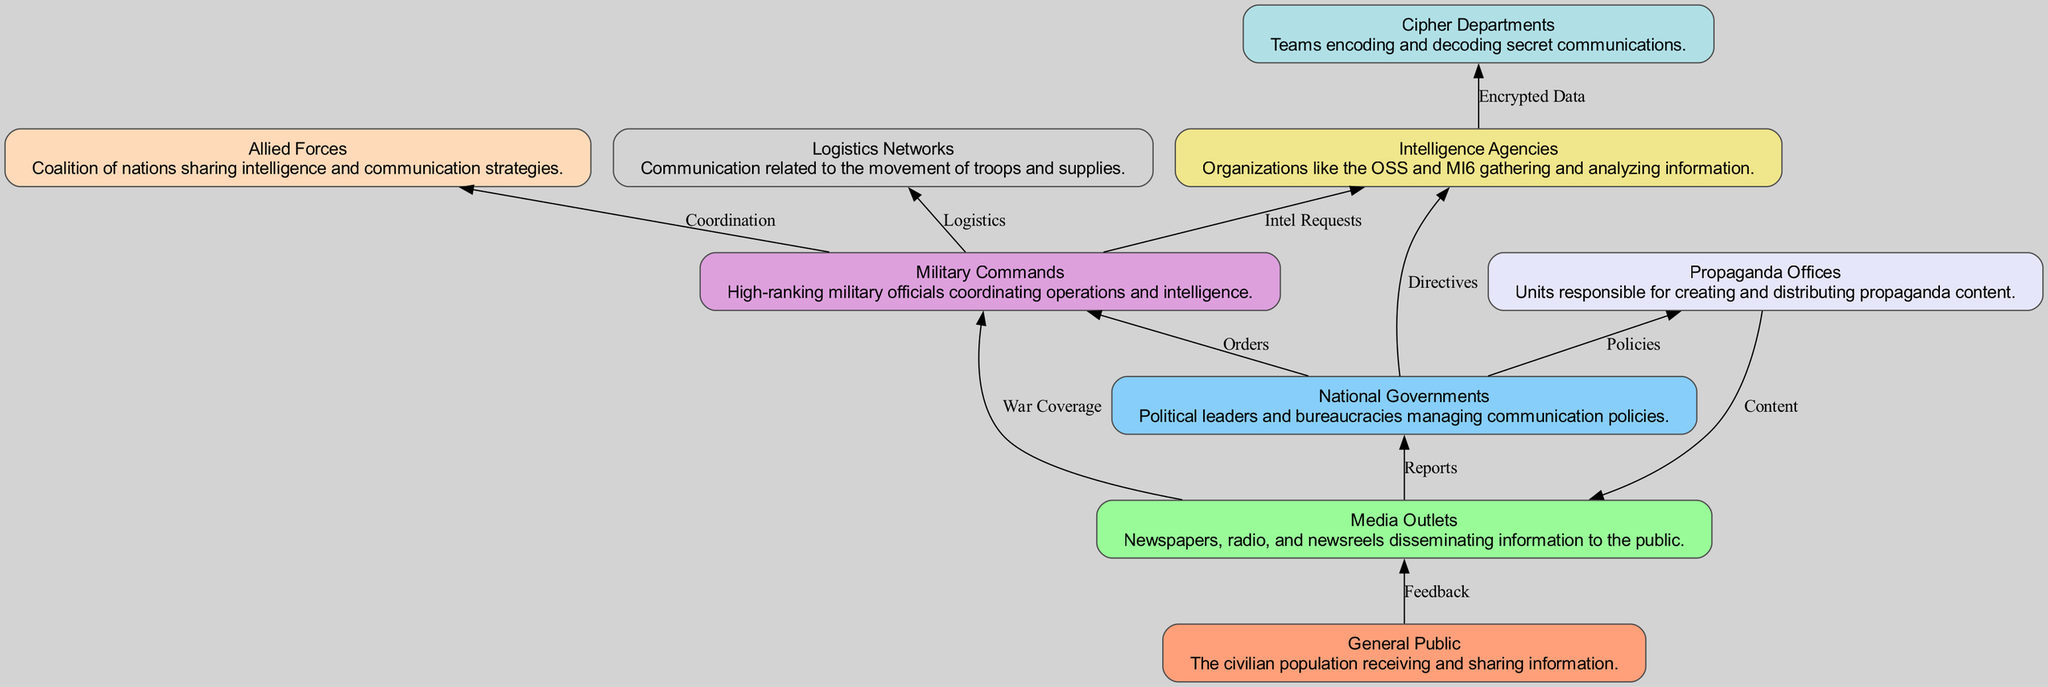What is the total number of nodes in the diagram? The diagram contains nodes representing different entities: General Public, Media Outlets, National Governments, Military Commands, Intelligence Agencies, Propaganda Offices, Allied Forces, Cipher Departments, and Logistics Networks. Counting these gives a total of 9 nodes.
Answer: 9 What is the relationship between the Media and the Government? In the diagram, the Media has a directed edge towards the Government, labeled as "Reports," indicating that Media Outlets send reports to National Governments.
Answer: Reports Who communicates directly with the Military for logistics? The diagram shows that the Military communicates with Logistics Networks with a directed edge labeled "Logistics." This means that Logistics Networks are responsible for facilitating communication about the movement of troops and supplies with the Military.
Answer: Logistics Networks Which entity is responsible for creating content shared by the Media? The directed edge from Propaganda Offices to Media Outlets, labeled "Content," indicates that the Propaganda Offices are responsible for creating content that is disseminated by the Media.
Answer: Propaganda Offices How many connections does the Intelligence Agencies have? By examining the edges leading into and out of Intelligence Agencies in the diagram, we see two connections: one from Governments labeled "Directives" and one to Ciphers labeled "Encrypted Data." So the total number of connections is 2.
Answer: 2 Who coordinates with the Military during operations? The diagram indicates that the Military communicates with the Allied Forces, which is represented by the directed edge labeled "Coordination." This shows that the Allied Forces are the ones coordinating with the Military.
Answer: Allied Forces Which entity receives feedback from the Public? The diagram depicts a directed edge from the General Public to Media Outlets labeled "Feedback," indicating that the General Public provides feedback to the Media.
Answer: Media Outlets What do the Ciphers' reports encompass? The directed edge from Intelligence Agencies to Ciphers, labeled "Encrypted Data," signifies that Ciphers report the encrypted data that they handle on behalf of Intelligence Agencies.
Answer: Encrypted Data What is the main function of the National Governments according to the diagram? Analyzing the links, the National Governments are shown to issue "Orders" to the Military Commands, set "Policies" to the Propaganda Offices, and send "Directives" to Intelligence Agencies, indicating that their main function is to manage and direct various communication policies and operations.
Answer: Manage communication policies 